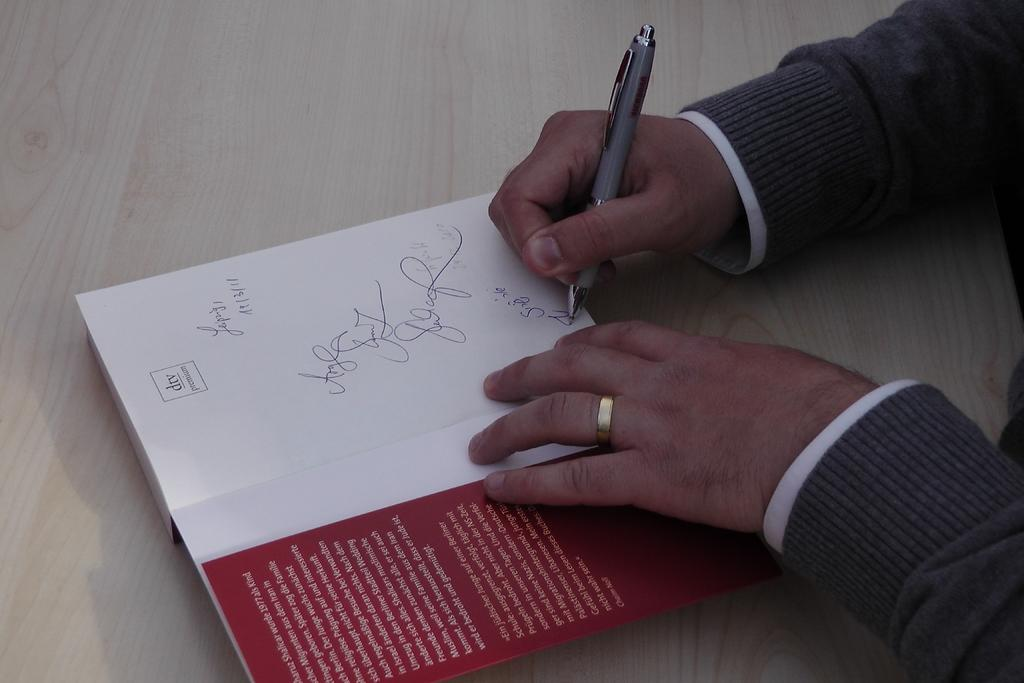What object is placed on the table in the image? There is a book on the table. What is the person holding in the image? The person is holding a pen. What is the person doing with the pen? The person is writing on the book. What type of stone is being used to attack the person in the image? There is no stone or attack present in the image; it features a person holding a pen and writing on a book. 